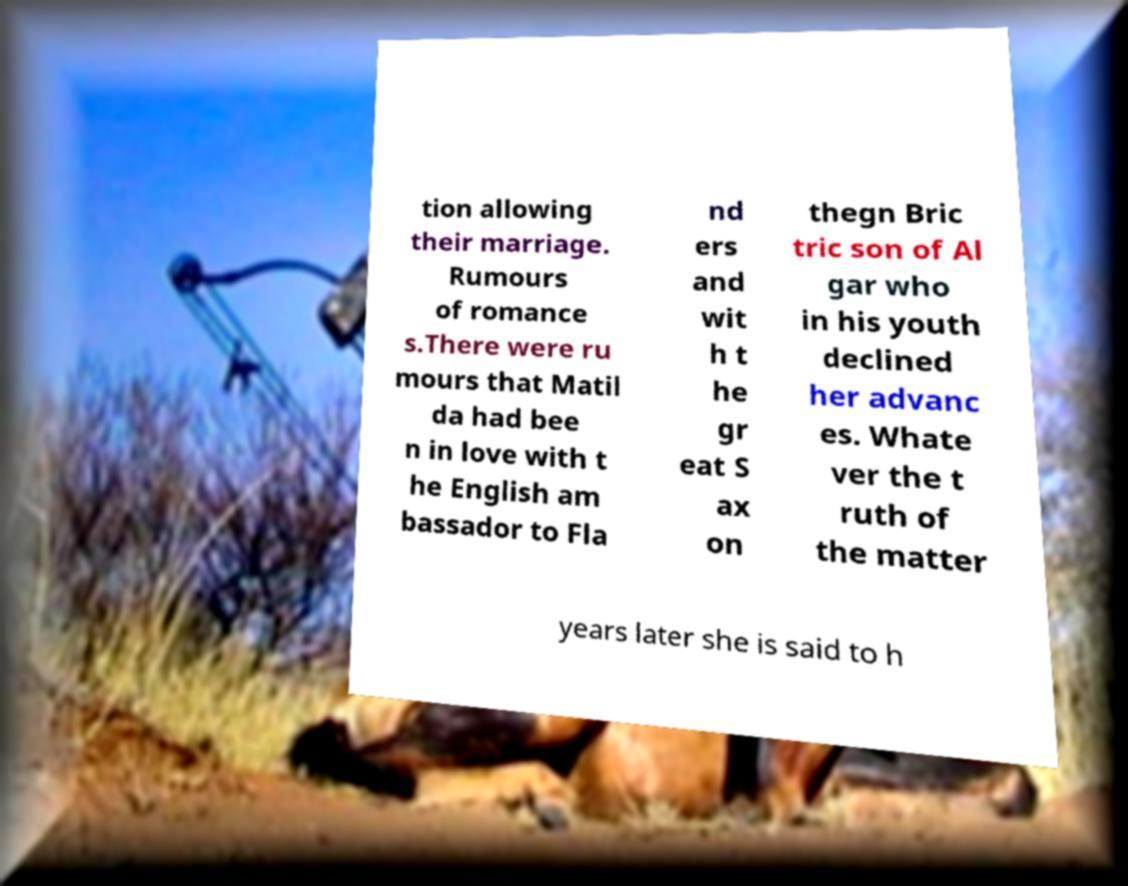Could you extract and type out the text from this image? tion allowing their marriage. Rumours of romance s.There were ru mours that Matil da had bee n in love with t he English am bassador to Fla nd ers and wit h t he gr eat S ax on thegn Bric tric son of Al gar who in his youth declined her advanc es. Whate ver the t ruth of the matter years later she is said to h 